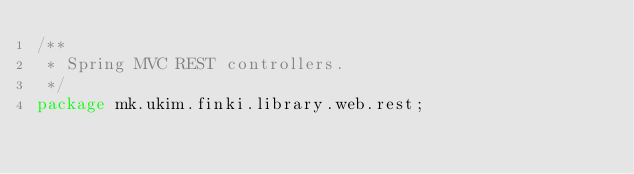Convert code to text. <code><loc_0><loc_0><loc_500><loc_500><_Java_>/**
 * Spring MVC REST controllers.
 */
package mk.ukim.finki.library.web.rest;
</code> 